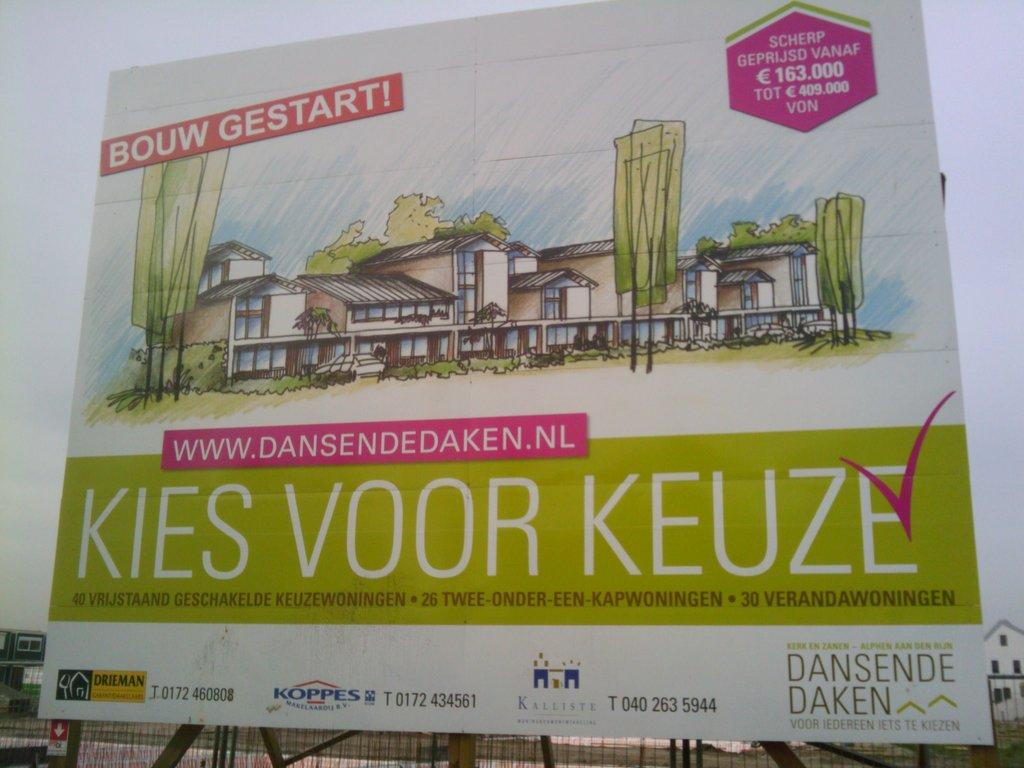<image>
Share a concise interpretation of the image provided. An architectural rendering in a sign to advertise a development in the Netherlands. 